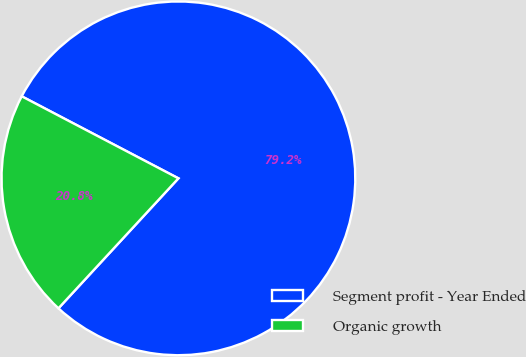Convert chart. <chart><loc_0><loc_0><loc_500><loc_500><pie_chart><fcel>Segment profit - Year Ended<fcel>Organic growth<nl><fcel>79.19%<fcel>20.81%<nl></chart> 